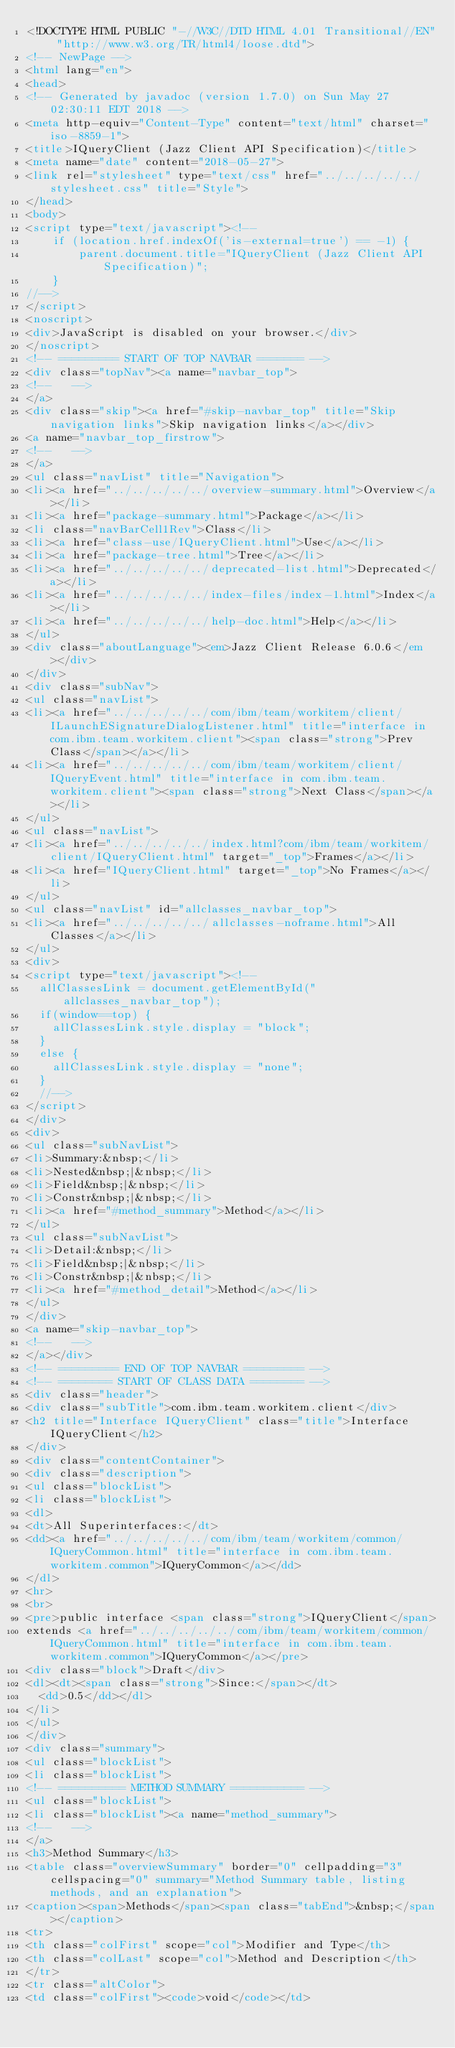<code> <loc_0><loc_0><loc_500><loc_500><_HTML_><!DOCTYPE HTML PUBLIC "-//W3C//DTD HTML 4.01 Transitional//EN" "http://www.w3.org/TR/html4/loose.dtd">
<!-- NewPage -->
<html lang="en">
<head>
<!-- Generated by javadoc (version 1.7.0) on Sun May 27 02:30:11 EDT 2018 -->
<meta http-equiv="Content-Type" content="text/html" charset="iso-8859-1">
<title>IQueryClient (Jazz Client API Specification)</title>
<meta name="date" content="2018-05-27">
<link rel="stylesheet" type="text/css" href="../../../../../stylesheet.css" title="Style">
</head>
<body>
<script type="text/javascript"><!--
    if (location.href.indexOf('is-external=true') == -1) {
        parent.document.title="IQueryClient (Jazz Client API Specification)";
    }
//-->
</script>
<noscript>
<div>JavaScript is disabled on your browser.</div>
</noscript>
<!-- ========= START OF TOP NAVBAR ======= -->
<div class="topNav"><a name="navbar_top">
<!--   -->
</a>
<div class="skip"><a href="#skip-navbar_top" title="Skip navigation links">Skip navigation links</a></div>
<a name="navbar_top_firstrow">
<!--   -->
</a>
<ul class="navList" title="Navigation">
<li><a href="../../../../../overview-summary.html">Overview</a></li>
<li><a href="package-summary.html">Package</a></li>
<li class="navBarCell1Rev">Class</li>
<li><a href="class-use/IQueryClient.html">Use</a></li>
<li><a href="package-tree.html">Tree</a></li>
<li><a href="../../../../../deprecated-list.html">Deprecated</a></li>
<li><a href="../../../../../index-files/index-1.html">Index</a></li>
<li><a href="../../../../../help-doc.html">Help</a></li>
</ul>
<div class="aboutLanguage"><em>Jazz Client Release 6.0.6</em></div>
</div>
<div class="subNav">
<ul class="navList">
<li><a href="../../../../../com/ibm/team/workitem/client/ILaunchESignatureDialogListener.html" title="interface in com.ibm.team.workitem.client"><span class="strong">Prev Class</span></a></li>
<li><a href="../../../../../com/ibm/team/workitem/client/IQueryEvent.html" title="interface in com.ibm.team.workitem.client"><span class="strong">Next Class</span></a></li>
</ul>
<ul class="navList">
<li><a href="../../../../../index.html?com/ibm/team/workitem/client/IQueryClient.html" target="_top">Frames</a></li>
<li><a href="IQueryClient.html" target="_top">No Frames</a></li>
</ul>
<ul class="navList" id="allclasses_navbar_top">
<li><a href="../../../../../allclasses-noframe.html">All Classes</a></li>
</ul>
<div>
<script type="text/javascript"><!--
  allClassesLink = document.getElementById("allclasses_navbar_top");
  if(window==top) {
    allClassesLink.style.display = "block";
  }
  else {
    allClassesLink.style.display = "none";
  }
  //-->
</script>
</div>
<div>
<ul class="subNavList">
<li>Summary:&nbsp;</li>
<li>Nested&nbsp;|&nbsp;</li>
<li>Field&nbsp;|&nbsp;</li>
<li>Constr&nbsp;|&nbsp;</li>
<li><a href="#method_summary">Method</a></li>
</ul>
<ul class="subNavList">
<li>Detail:&nbsp;</li>
<li>Field&nbsp;|&nbsp;</li>
<li>Constr&nbsp;|&nbsp;</li>
<li><a href="#method_detail">Method</a></li>
</ul>
</div>
<a name="skip-navbar_top">
<!--   -->
</a></div>
<!-- ========= END OF TOP NAVBAR ========= -->
<!-- ======== START OF CLASS DATA ======== -->
<div class="header">
<div class="subTitle">com.ibm.team.workitem.client</div>
<h2 title="Interface IQueryClient" class="title">Interface IQueryClient</h2>
</div>
<div class="contentContainer">
<div class="description">
<ul class="blockList">
<li class="blockList">
<dl>
<dt>All Superinterfaces:</dt>
<dd><a href="../../../../../com/ibm/team/workitem/common/IQueryCommon.html" title="interface in com.ibm.team.workitem.common">IQueryCommon</a></dd>
</dl>
<hr>
<br>
<pre>public interface <span class="strong">IQueryClient</span>
extends <a href="../../../../../com/ibm/team/workitem/common/IQueryCommon.html" title="interface in com.ibm.team.workitem.common">IQueryCommon</a></pre>
<div class="block">Draft</div>
<dl><dt><span class="strong">Since:</span></dt>
  <dd>0.5</dd></dl>
</li>
</ul>
</div>
<div class="summary">
<ul class="blockList">
<li class="blockList">
<!-- ========== METHOD SUMMARY =========== -->
<ul class="blockList">
<li class="blockList"><a name="method_summary">
<!--   -->
</a>
<h3>Method Summary</h3>
<table class="overviewSummary" border="0" cellpadding="3" cellspacing="0" summary="Method Summary table, listing methods, and an explanation">
<caption><span>Methods</span><span class="tabEnd">&nbsp;</span></caption>
<tr>
<th class="colFirst" scope="col">Modifier and Type</th>
<th class="colLast" scope="col">Method and Description</th>
</tr>
<tr class="altColor">
<td class="colFirst"><code>void</code></td></code> 